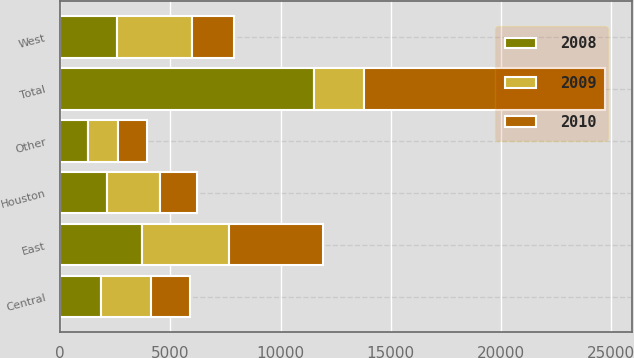Convert chart to OTSL. <chart><loc_0><loc_0><loc_500><loc_500><stacked_bar_chart><ecel><fcel>East<fcel>Central<fcel>West<fcel>Houston<fcel>Other<fcel>Total<nl><fcel>2010<fcel>4270<fcel>1769<fcel>1922<fcel>1641<fcel>1326<fcel>10928<nl><fcel>2008<fcel>3710<fcel>1840<fcel>2569<fcel>2130<fcel>1261<fcel>11510<nl><fcel>2009<fcel>3953<fcel>2280<fcel>3396<fcel>2416<fcel>1346<fcel>2280<nl></chart> 